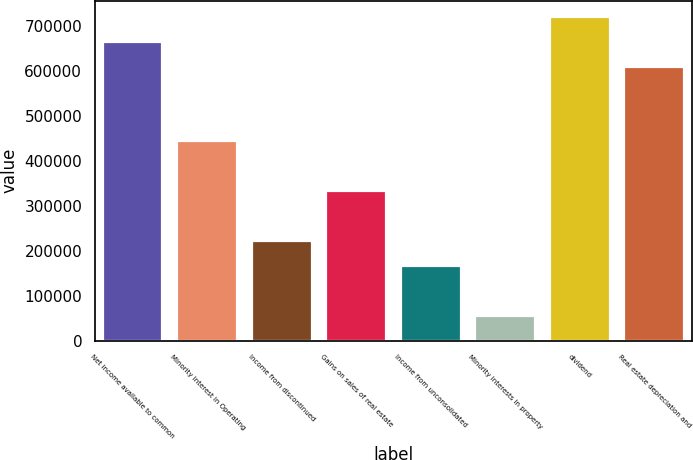<chart> <loc_0><loc_0><loc_500><loc_500><bar_chart><fcel>Net income available to common<fcel>Minority interest in Operating<fcel>Income from discontinued<fcel>Gains on sales of real estate<fcel>Income from unconsolidated<fcel>Minority interests in property<fcel>dividend<fcel>Real estate depreciation and<nl><fcel>664578<fcel>443080<fcel>221581<fcel>332331<fcel>166207<fcel>55457.6<fcel>719953<fcel>609204<nl></chart> 